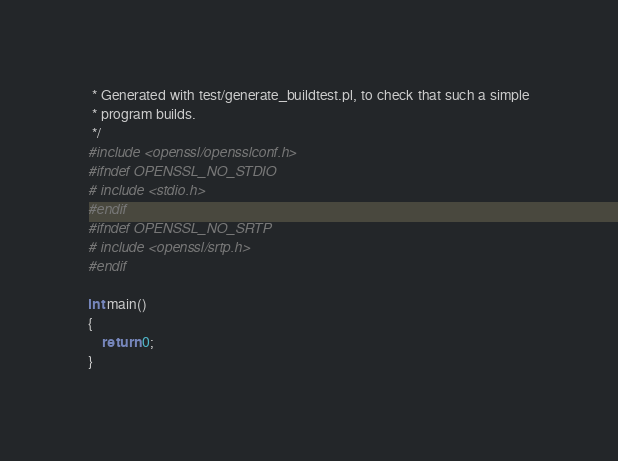Convert code to text. <code><loc_0><loc_0><loc_500><loc_500><_C_> * Generated with test/generate_buildtest.pl, to check that such a simple
 * program builds.
 */
#include <openssl/opensslconf.h>
#ifndef OPENSSL_NO_STDIO
# include <stdio.h>
#endif
#ifndef OPENSSL_NO_SRTP
# include <openssl/srtp.h>
#endif

int main()
{
    return 0;
}
</code> 